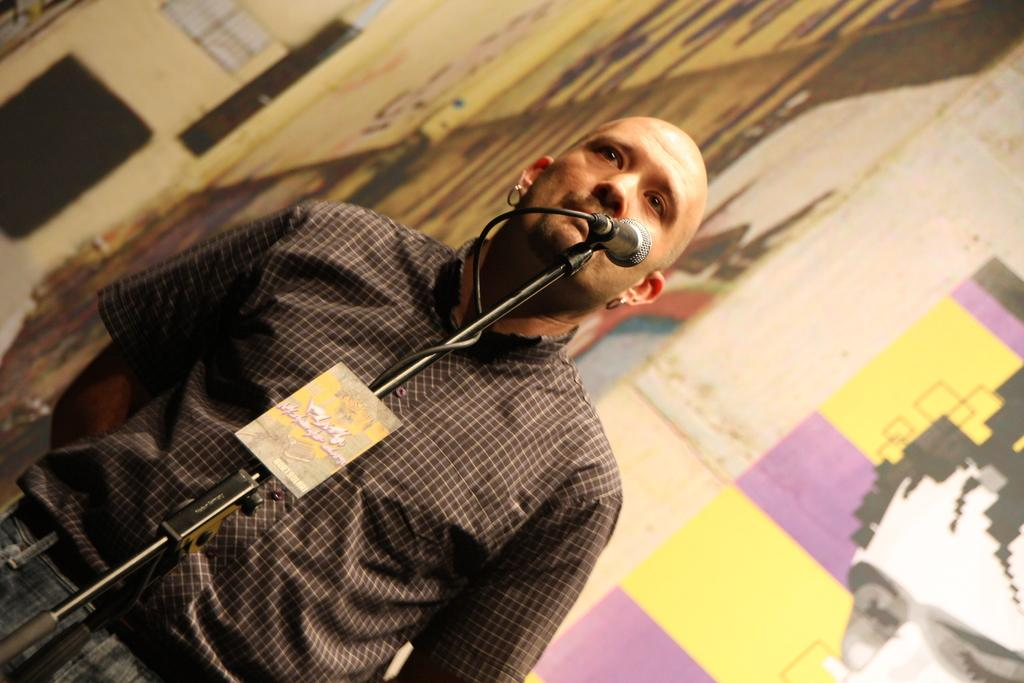What equipment is located in the front of the image? There is a mic and a stand in the front of the image. Who is positioned near the mic? There is a person standing behind the mic. What can be seen in the background of the image? There is a wall in the background of the image. What decorative element is present on the wall? There is a painting on the wall in the background. What type of weather can be seen in the image? The image does not depict any weather conditions; it is an indoor scene with a person standing behind a mic and a painting on the wall. 